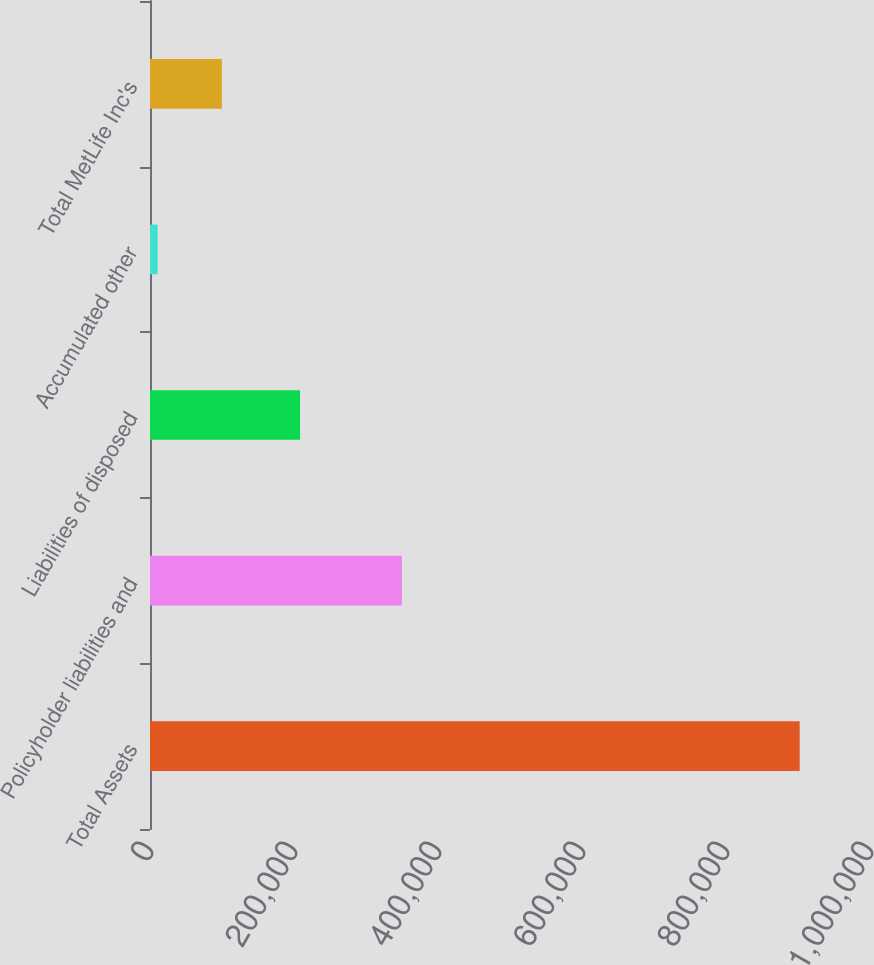Convert chart. <chart><loc_0><loc_0><loc_500><loc_500><bar_chart><fcel>Total Assets<fcel>Policyholder liabilities and<fcel>Liabilities of disposed<fcel>Accumulated other<fcel>Total MetLife Inc's<nl><fcel>902337<fcel>349845<fcel>208406<fcel>10649<fcel>99817.8<nl></chart> 